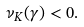Convert formula to latex. <formula><loc_0><loc_0><loc_500><loc_500>\nu _ { K } ( \gamma ) < 0 .</formula> 